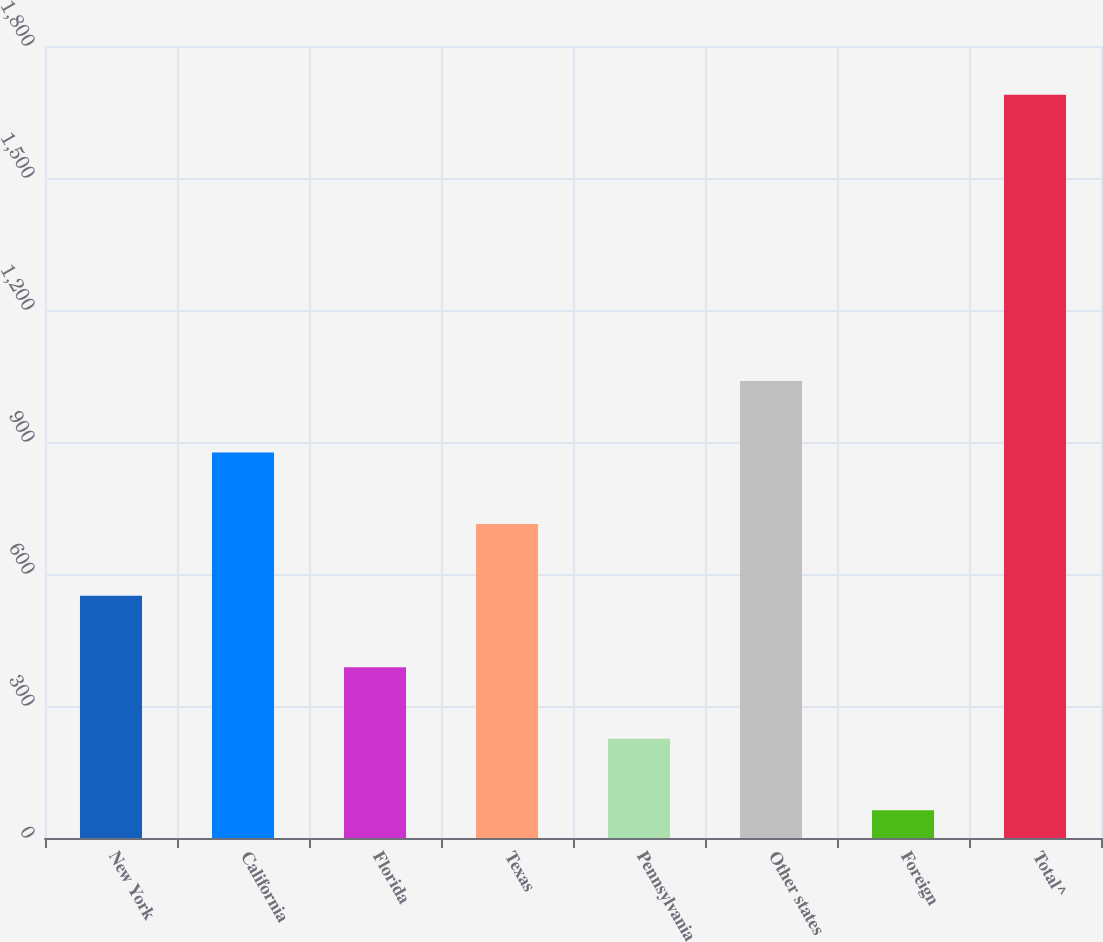Convert chart. <chart><loc_0><loc_0><loc_500><loc_500><bar_chart><fcel>New York<fcel>California<fcel>Florida<fcel>Texas<fcel>Pennsylvania<fcel>Other states<fcel>Foreign<fcel>Total^<nl><fcel>550.8<fcel>876<fcel>388.2<fcel>713.4<fcel>225.6<fcel>1038.6<fcel>63<fcel>1689<nl></chart> 